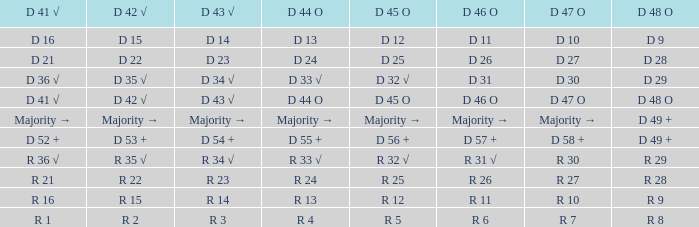Name the D 47 O with D 48 O of r 9 R 10. 